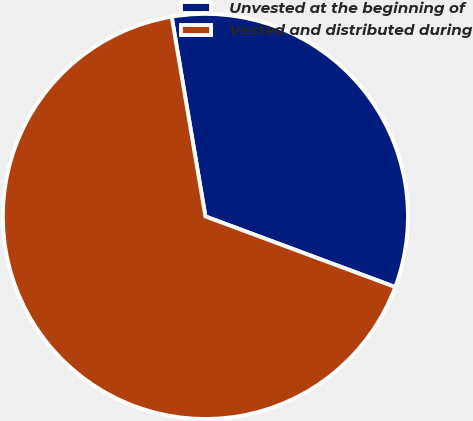Convert chart. <chart><loc_0><loc_0><loc_500><loc_500><pie_chart><fcel>Unvested at the beginning of<fcel>Vested and distributed during<nl><fcel>33.33%<fcel>66.67%<nl></chart> 